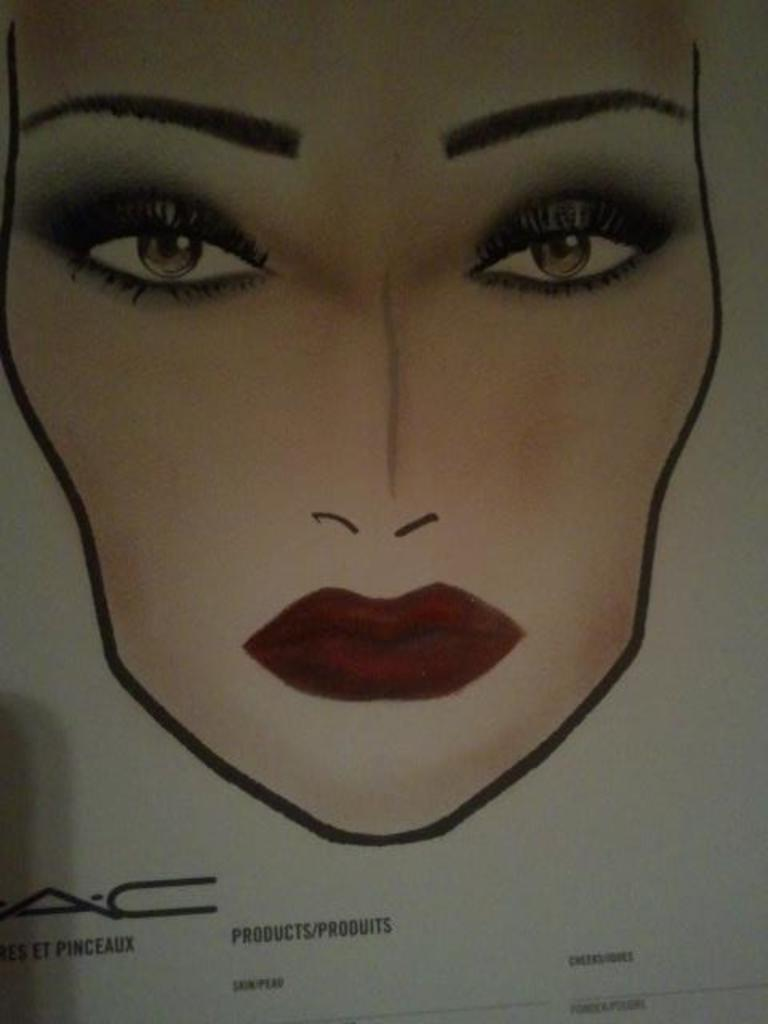What is depicted on the paper in the image? There is a drawing of a person's face in the image. Are there any other elements on the paper besides the drawing? Yes, there are words on the paper in the image. How many dogs are present in the image? There are no dogs present in the image; it features a drawing of a person's face and words on a paper. What type of weather is depicted in the image? The image does not depict any weather conditions, as it focuses on a drawing of a person's face and words on a paper. 